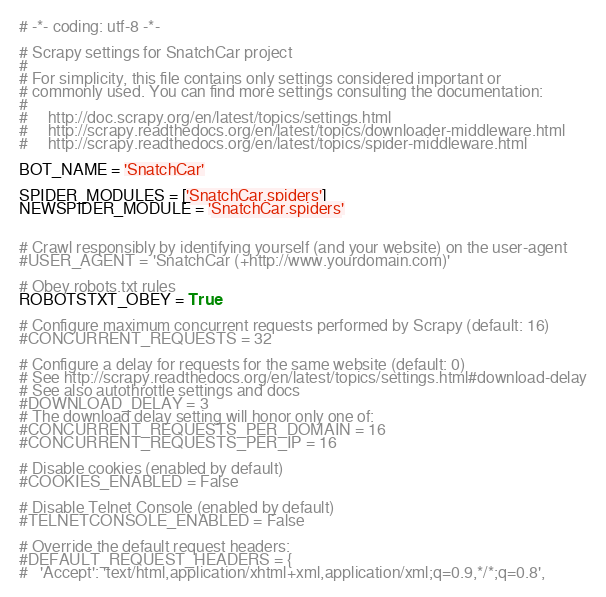Convert code to text. <code><loc_0><loc_0><loc_500><loc_500><_Python_># -*- coding: utf-8 -*-

# Scrapy settings for SnatchCar project
#
# For simplicity, this file contains only settings considered important or
# commonly used. You can find more settings consulting the documentation:
#
#     http://doc.scrapy.org/en/latest/topics/settings.html
#     http://scrapy.readthedocs.org/en/latest/topics/downloader-middleware.html
#     http://scrapy.readthedocs.org/en/latest/topics/spider-middleware.html

BOT_NAME = 'SnatchCar'

SPIDER_MODULES = ['SnatchCar.spiders']
NEWSPIDER_MODULE = 'SnatchCar.spiders'


# Crawl responsibly by identifying yourself (and your website) on the user-agent
#USER_AGENT = 'SnatchCar (+http://www.yourdomain.com)'

# Obey robots.txt rules
ROBOTSTXT_OBEY = True

# Configure maximum concurrent requests performed by Scrapy (default: 16)
#CONCURRENT_REQUESTS = 32

# Configure a delay for requests for the same website (default: 0)
# See http://scrapy.readthedocs.org/en/latest/topics/settings.html#download-delay
# See also autothrottle settings and docs
#DOWNLOAD_DELAY = 3
# The download delay setting will honor only one of:
#CONCURRENT_REQUESTS_PER_DOMAIN = 16
#CONCURRENT_REQUESTS_PER_IP = 16

# Disable cookies (enabled by default)
#COOKIES_ENABLED = False

# Disable Telnet Console (enabled by default)
#TELNETCONSOLE_ENABLED = False

# Override the default request headers:
#DEFAULT_REQUEST_HEADERS = {
#   'Accept': 'text/html,application/xhtml+xml,application/xml;q=0.9,*/*;q=0.8',</code> 